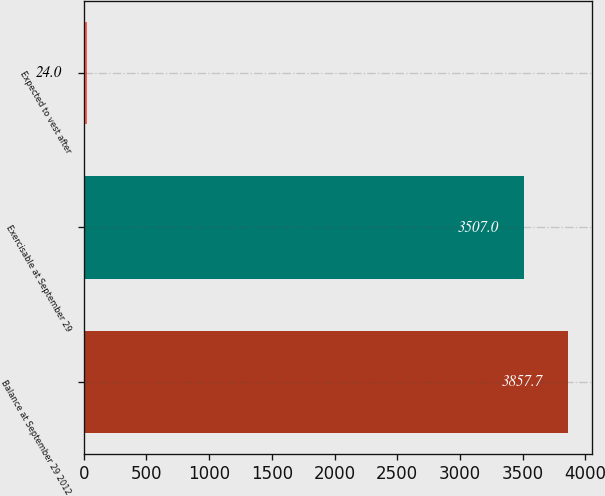Convert chart to OTSL. <chart><loc_0><loc_0><loc_500><loc_500><bar_chart><fcel>Balance at September 29 2012<fcel>Exercisable at September 29<fcel>Expected to vest after<nl><fcel>3857.7<fcel>3507<fcel>24<nl></chart> 